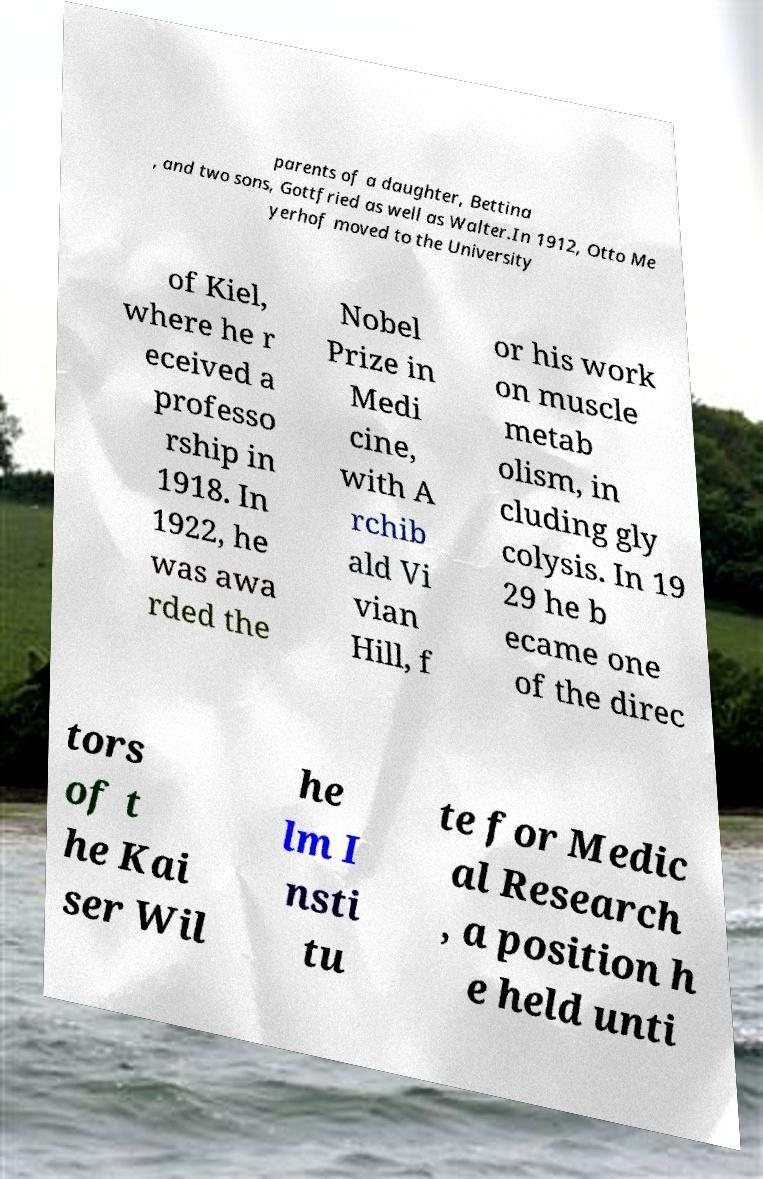For documentation purposes, I need the text within this image transcribed. Could you provide that? parents of a daughter, Bettina , and two sons, Gottfried as well as Walter.In 1912, Otto Me yerhof moved to the University of Kiel, where he r eceived a professo rship in 1918. In 1922, he was awa rded the Nobel Prize in Medi cine, with A rchib ald Vi vian Hill, f or his work on muscle metab olism, in cluding gly colysis. In 19 29 he b ecame one of the direc tors of t he Kai ser Wil he lm I nsti tu te for Medic al Research , a position h e held unti 